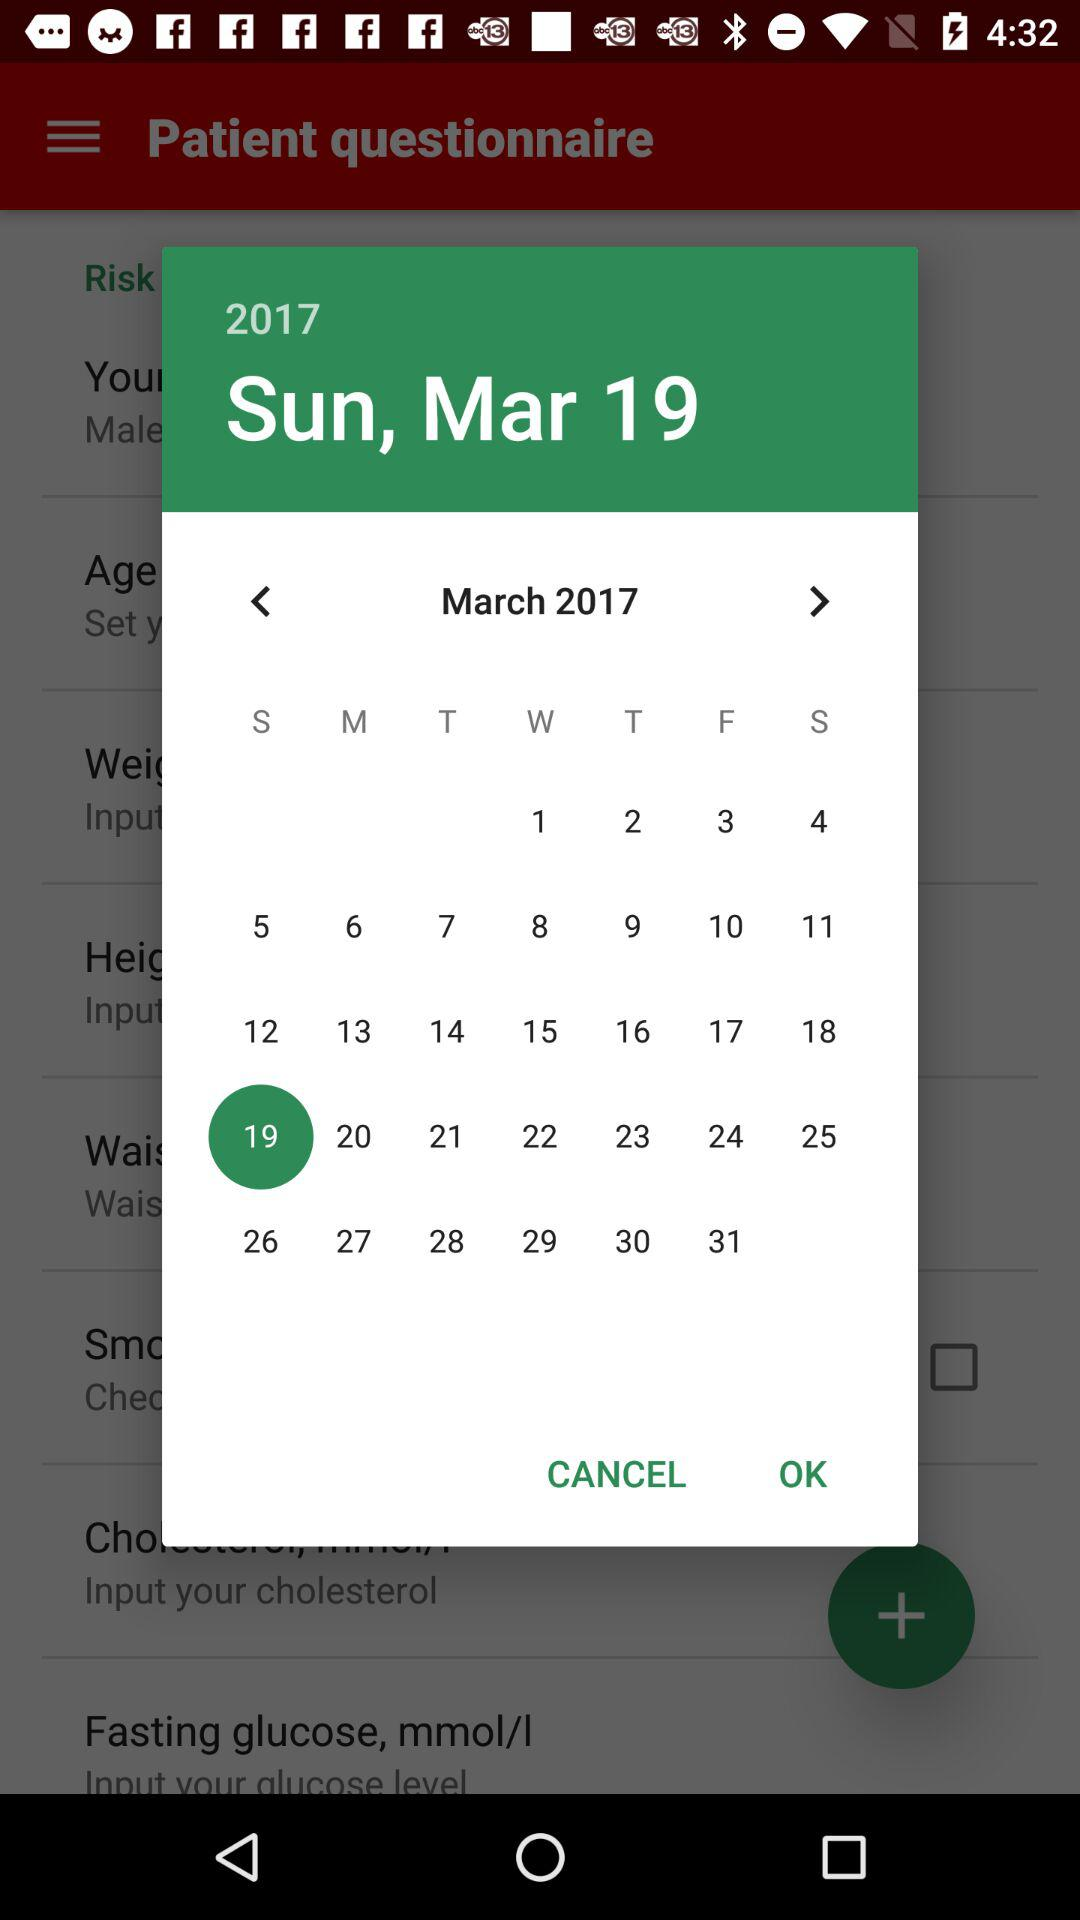What is the day on March 19? The day is Sunday. 